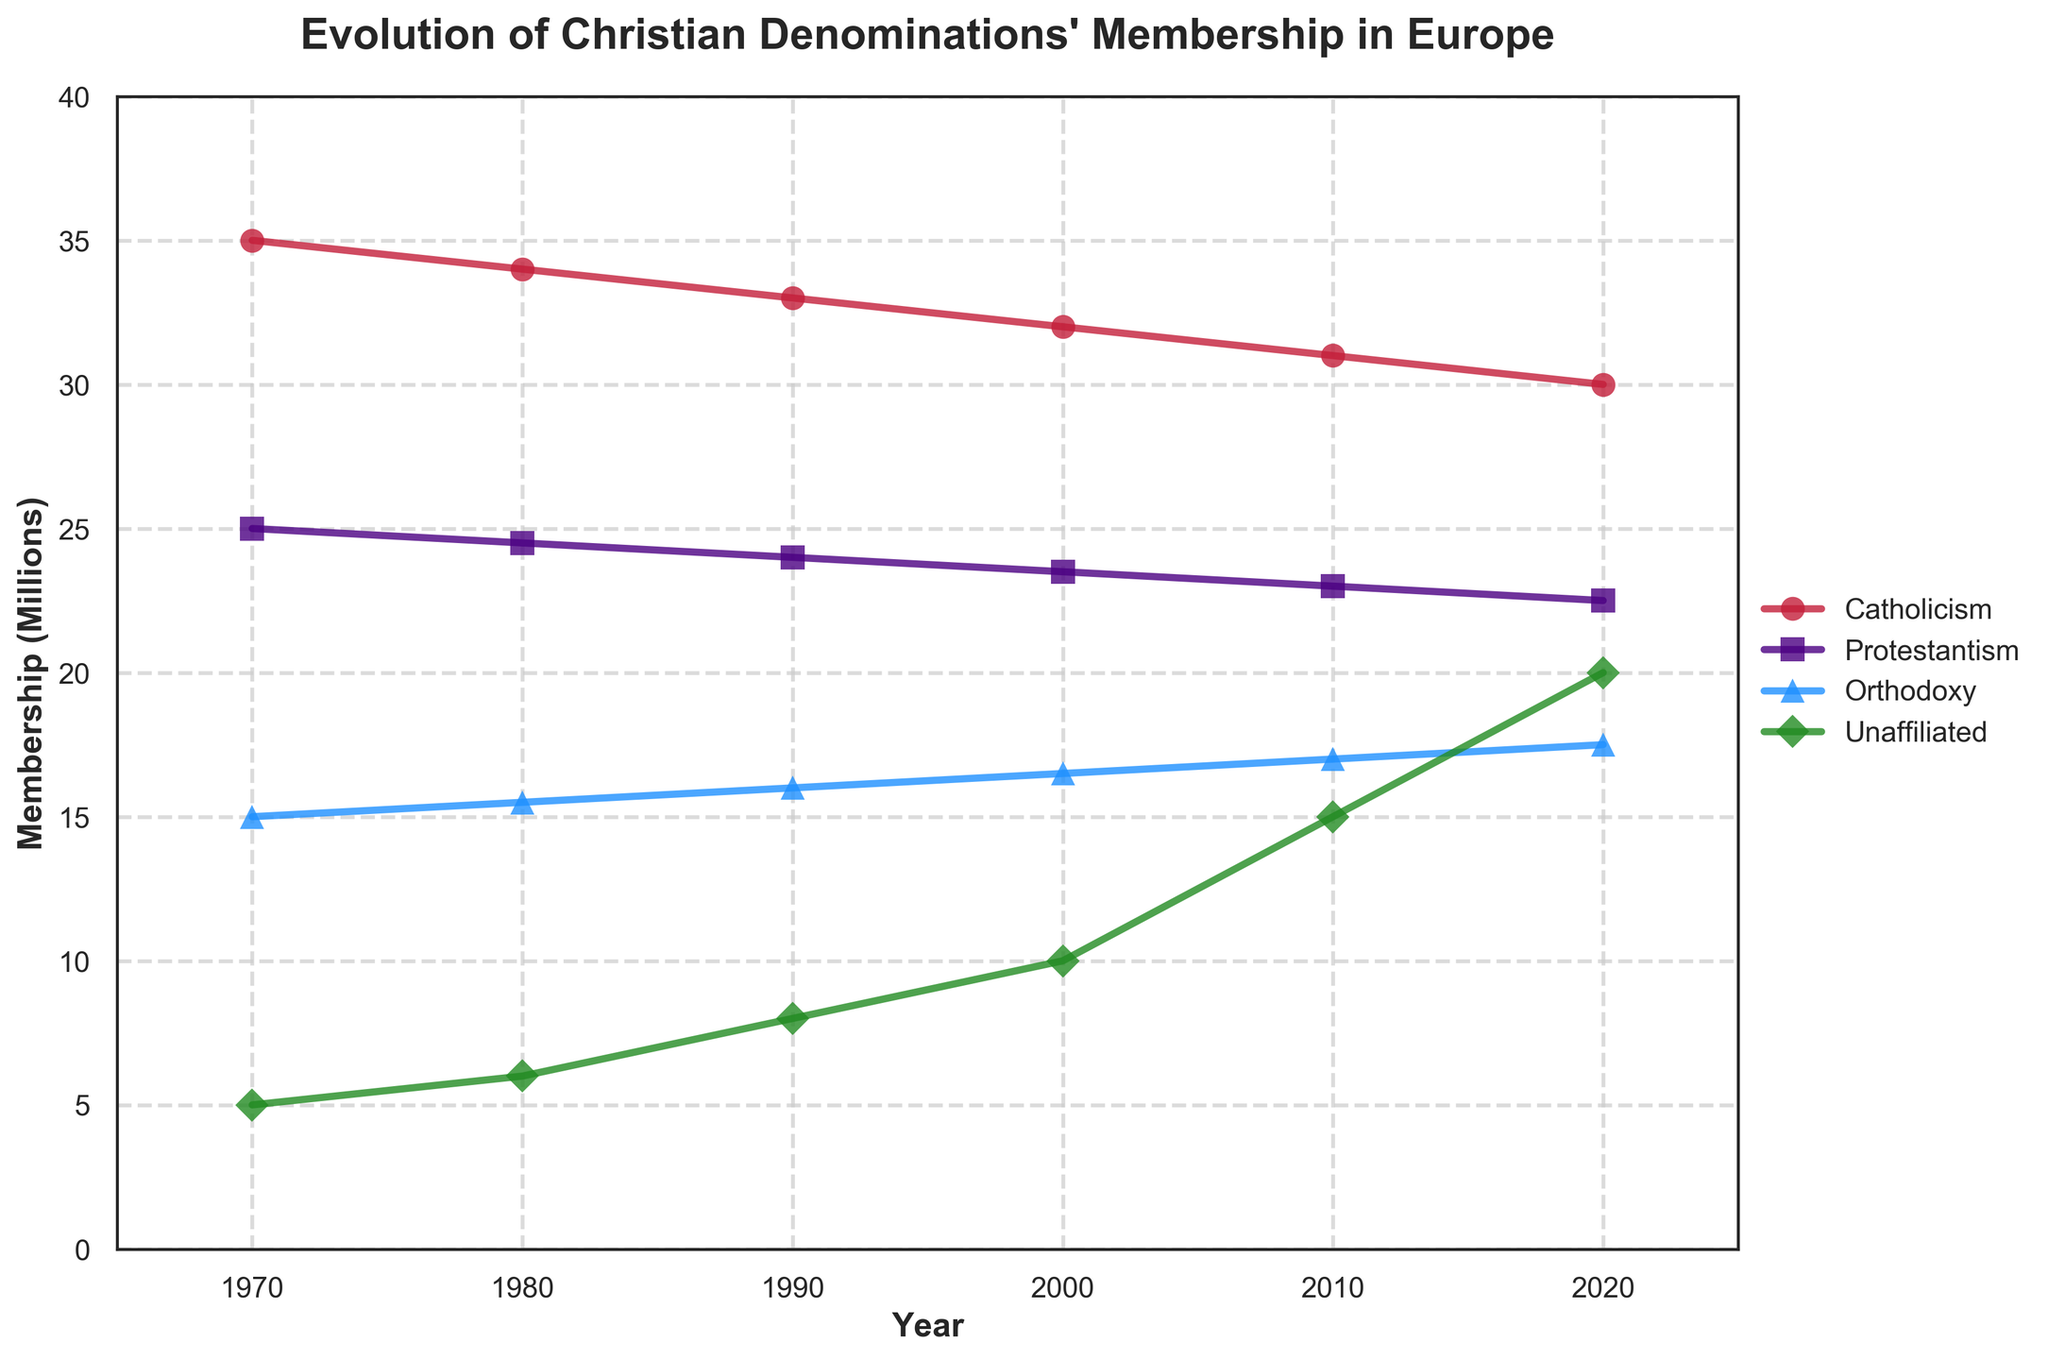What is the title of the plot? The title of the plot is displayed at the top of the figure.
Answer: Evolution of Christian Denominations' Membership in Europe What is the membership of Catholicism in the year 1980 in millions? Look at the value corresponding to "Catholicism" in the year 1980 and convert it to millions.
Answer: 34 Between which years does the plot show data? Identify the range of years displayed along the x-axis of the plot.
Answer: 1970 to 2020 Which denomination has the highest membership in 2020? Compare the membership values of all denominations in the year 2020.
Answer: Catholicism How many data points are there for each denomination? Count the number of distinct years shown in the plot.
Answer: 6 By how much did the membership of Orthodoxy increase from 1970 to 2020? Subtract the membership value of Orthodoxy in 1970 from its value in 2020.
Answer: 2.5 million What is the difference in membership between Catholicism and Protestantism in 2010? Find the membership values of Catholicism and Protestantism in 2010 and subtract the smaller value from the larger value.
Answer: 8 million Which denomination shows the most significant increase in unaffiliated people from 1970 to 2020? Observe the change in the values of unaffiliated individuals from 1970 to 2020.
Answer: Unaffiliated Did any denomination's membership remain constant over the years? Examine the trend of each denomination's membership over time to see if any line remains flat.
Answer: No What is the average membership of Protestantism from 1980 to 2000? Sum the membership values of Protestantism for the years 1980, 1990, and 2000, then divide by 3.
Answer: 24 million 